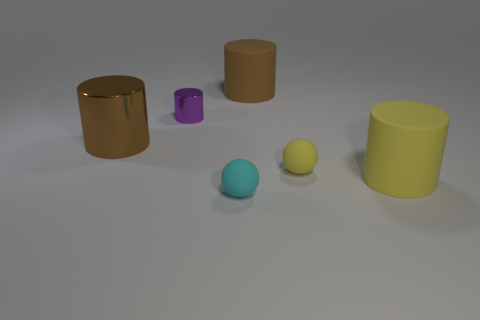Subtract all purple cylinders. How many cylinders are left? 3 Subtract 2 cylinders. How many cylinders are left? 2 Subtract all green cylinders. Subtract all brown blocks. How many cylinders are left? 4 Add 4 cyan cylinders. How many objects exist? 10 Subtract all spheres. How many objects are left? 4 Subtract all cylinders. Subtract all small metal cylinders. How many objects are left? 1 Add 5 small yellow balls. How many small yellow balls are left? 6 Add 4 large metallic cylinders. How many large metallic cylinders exist? 5 Subtract 1 cyan spheres. How many objects are left? 5 